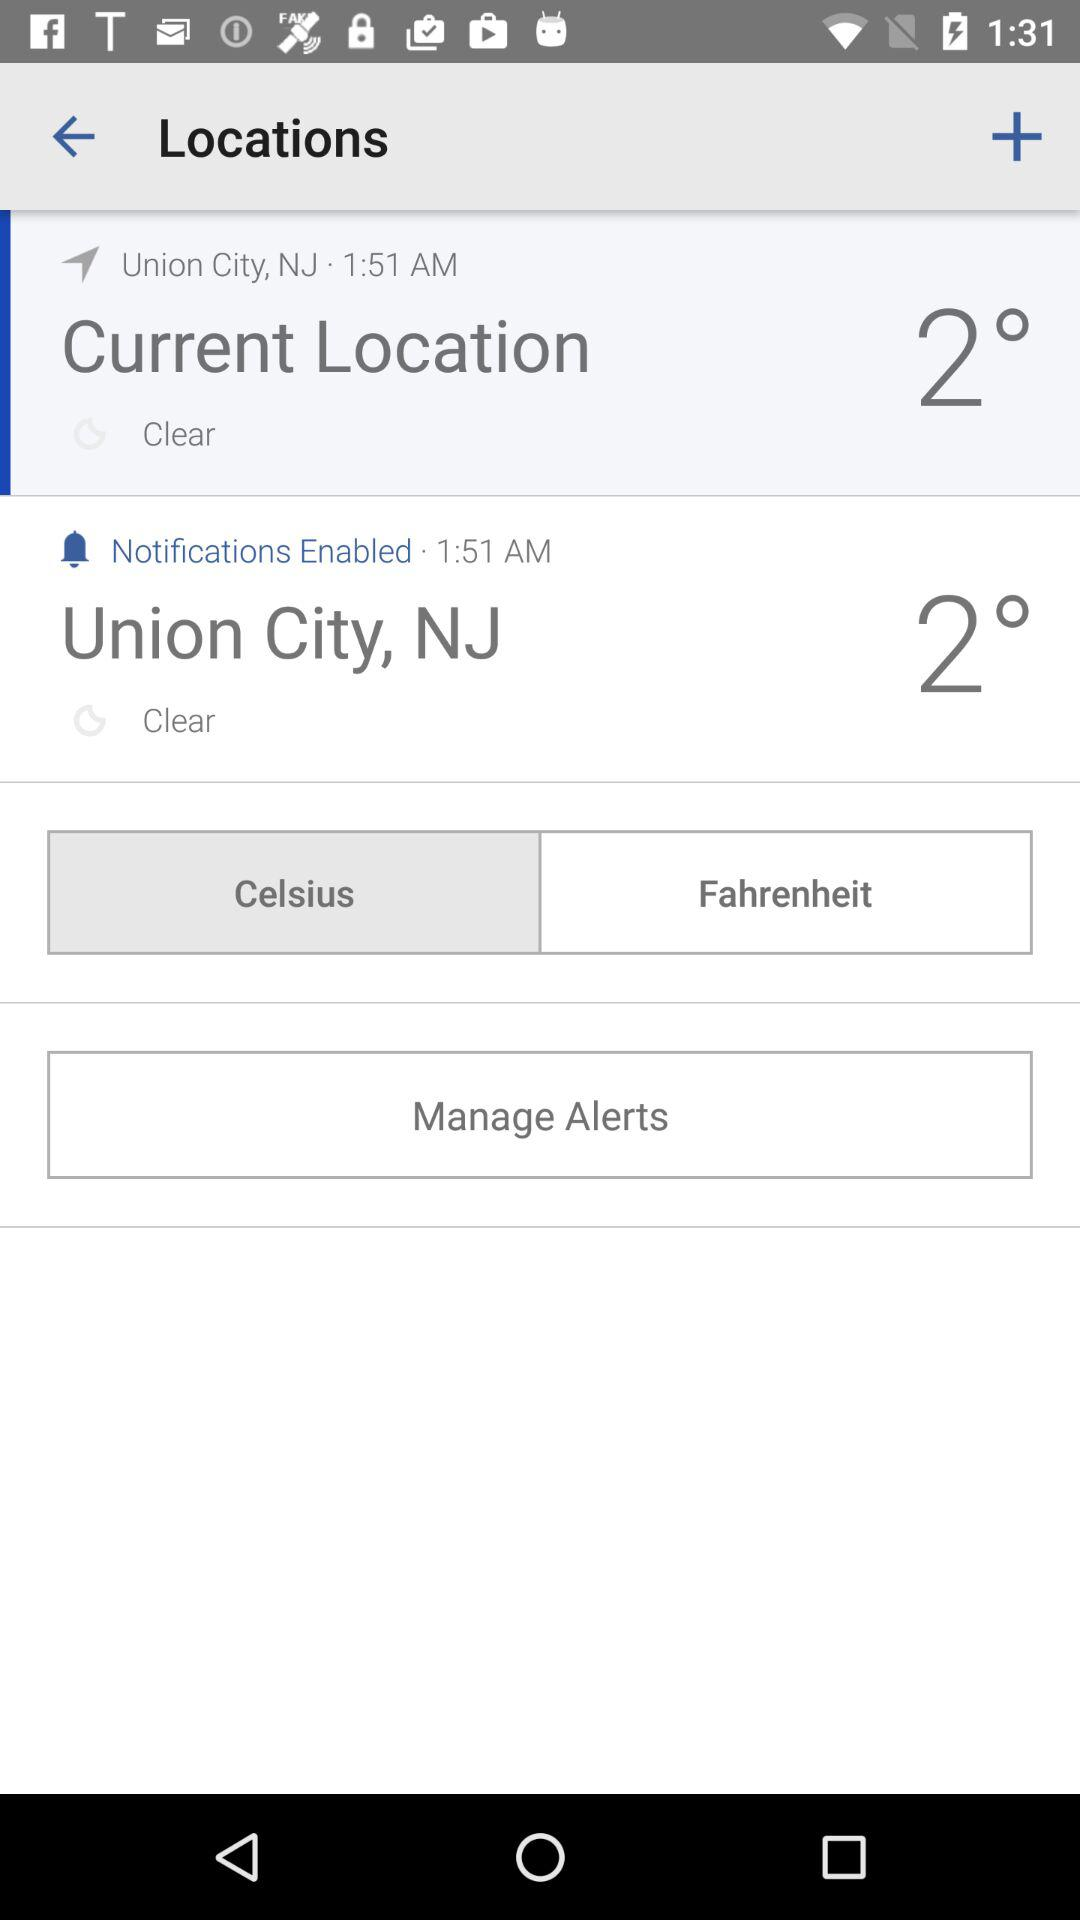What is the temperature in Union City? The temperature is 2°. 